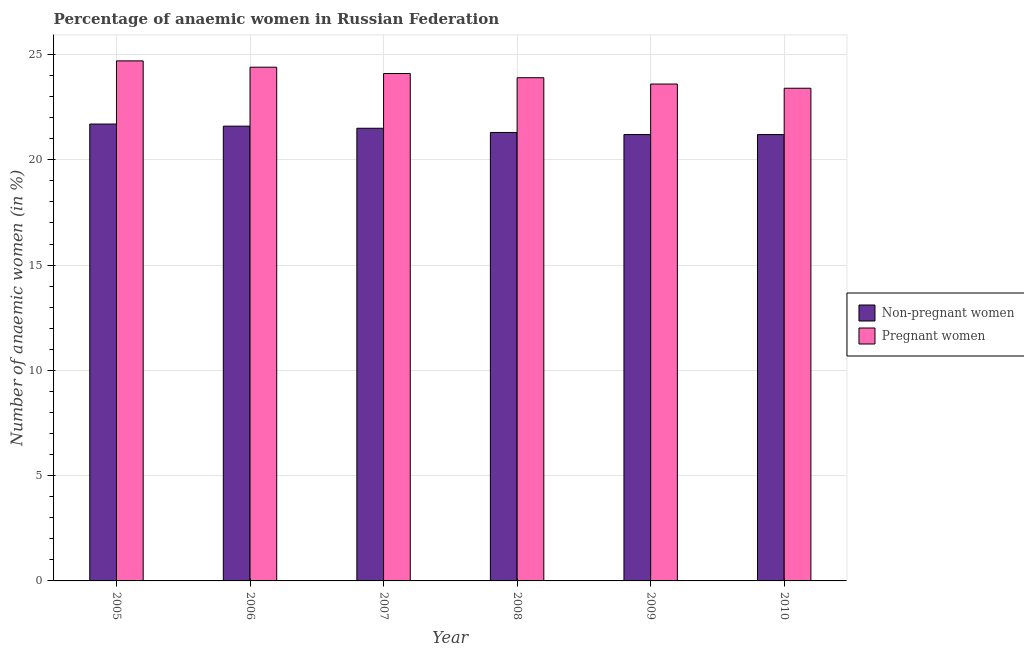How many different coloured bars are there?
Ensure brevity in your answer.  2. How many groups of bars are there?
Provide a short and direct response. 6. Are the number of bars per tick equal to the number of legend labels?
Your answer should be very brief. Yes. Are the number of bars on each tick of the X-axis equal?
Provide a succinct answer. Yes. How many bars are there on the 3rd tick from the left?
Your answer should be very brief. 2. What is the label of the 2nd group of bars from the left?
Offer a terse response. 2006. What is the percentage of non-pregnant anaemic women in 2006?
Ensure brevity in your answer.  21.6. Across all years, what is the maximum percentage of pregnant anaemic women?
Make the answer very short. 24.7. Across all years, what is the minimum percentage of non-pregnant anaemic women?
Give a very brief answer. 21.2. What is the total percentage of pregnant anaemic women in the graph?
Give a very brief answer. 144.1. What is the difference between the percentage of non-pregnant anaemic women in 2007 and that in 2010?
Keep it short and to the point. 0.3. What is the difference between the percentage of non-pregnant anaemic women in 2005 and the percentage of pregnant anaemic women in 2006?
Offer a terse response. 0.1. What is the average percentage of non-pregnant anaemic women per year?
Make the answer very short. 21.42. What is the ratio of the percentage of non-pregnant anaemic women in 2006 to that in 2007?
Make the answer very short. 1. What is the difference between the highest and the second highest percentage of pregnant anaemic women?
Provide a succinct answer. 0.3. What does the 2nd bar from the left in 2005 represents?
Give a very brief answer. Pregnant women. What does the 2nd bar from the right in 2006 represents?
Give a very brief answer. Non-pregnant women. How many bars are there?
Your answer should be very brief. 12. Are all the bars in the graph horizontal?
Ensure brevity in your answer.  No. How many years are there in the graph?
Provide a short and direct response. 6. Are the values on the major ticks of Y-axis written in scientific E-notation?
Give a very brief answer. No. Does the graph contain grids?
Ensure brevity in your answer.  Yes. How many legend labels are there?
Provide a succinct answer. 2. How are the legend labels stacked?
Provide a succinct answer. Vertical. What is the title of the graph?
Offer a very short reply. Percentage of anaemic women in Russian Federation. What is the label or title of the Y-axis?
Offer a terse response. Number of anaemic women (in %). What is the Number of anaemic women (in %) in Non-pregnant women in 2005?
Your response must be concise. 21.7. What is the Number of anaemic women (in %) of Pregnant women in 2005?
Your response must be concise. 24.7. What is the Number of anaemic women (in %) in Non-pregnant women in 2006?
Give a very brief answer. 21.6. What is the Number of anaemic women (in %) of Pregnant women in 2006?
Your answer should be very brief. 24.4. What is the Number of anaemic women (in %) in Pregnant women in 2007?
Give a very brief answer. 24.1. What is the Number of anaemic women (in %) in Non-pregnant women in 2008?
Keep it short and to the point. 21.3. What is the Number of anaemic women (in %) in Pregnant women in 2008?
Provide a succinct answer. 23.9. What is the Number of anaemic women (in %) of Non-pregnant women in 2009?
Your answer should be very brief. 21.2. What is the Number of anaemic women (in %) in Pregnant women in 2009?
Keep it short and to the point. 23.6. What is the Number of anaemic women (in %) of Non-pregnant women in 2010?
Provide a succinct answer. 21.2. What is the Number of anaemic women (in %) in Pregnant women in 2010?
Your answer should be compact. 23.4. Across all years, what is the maximum Number of anaemic women (in %) of Non-pregnant women?
Ensure brevity in your answer.  21.7. Across all years, what is the maximum Number of anaemic women (in %) of Pregnant women?
Offer a very short reply. 24.7. Across all years, what is the minimum Number of anaemic women (in %) in Non-pregnant women?
Give a very brief answer. 21.2. Across all years, what is the minimum Number of anaemic women (in %) in Pregnant women?
Your answer should be compact. 23.4. What is the total Number of anaemic women (in %) of Non-pregnant women in the graph?
Make the answer very short. 128.5. What is the total Number of anaemic women (in %) in Pregnant women in the graph?
Offer a very short reply. 144.1. What is the difference between the Number of anaemic women (in %) of Non-pregnant women in 2005 and that in 2006?
Offer a very short reply. 0.1. What is the difference between the Number of anaemic women (in %) in Pregnant women in 2005 and that in 2006?
Your answer should be compact. 0.3. What is the difference between the Number of anaemic women (in %) in Non-pregnant women in 2006 and that in 2008?
Your answer should be very brief. 0.3. What is the difference between the Number of anaemic women (in %) in Pregnant women in 2006 and that in 2008?
Offer a terse response. 0.5. What is the difference between the Number of anaemic women (in %) of Non-pregnant women in 2007 and that in 2008?
Provide a succinct answer. 0.2. What is the difference between the Number of anaemic women (in %) of Pregnant women in 2007 and that in 2008?
Your answer should be compact. 0.2. What is the difference between the Number of anaemic women (in %) of Non-pregnant women in 2007 and that in 2010?
Keep it short and to the point. 0.3. What is the difference between the Number of anaemic women (in %) of Pregnant women in 2007 and that in 2010?
Your answer should be compact. 0.7. What is the difference between the Number of anaemic women (in %) of Non-pregnant women in 2008 and that in 2009?
Offer a terse response. 0.1. What is the difference between the Number of anaemic women (in %) in Pregnant women in 2008 and that in 2009?
Keep it short and to the point. 0.3. What is the difference between the Number of anaemic women (in %) in Pregnant women in 2008 and that in 2010?
Your answer should be compact. 0.5. What is the difference between the Number of anaemic women (in %) in Non-pregnant women in 2005 and the Number of anaemic women (in %) in Pregnant women in 2007?
Provide a short and direct response. -2.4. What is the difference between the Number of anaemic women (in %) in Non-pregnant women in 2005 and the Number of anaemic women (in %) in Pregnant women in 2009?
Your response must be concise. -1.9. What is the difference between the Number of anaemic women (in %) of Non-pregnant women in 2005 and the Number of anaemic women (in %) of Pregnant women in 2010?
Keep it short and to the point. -1.7. What is the difference between the Number of anaemic women (in %) of Non-pregnant women in 2006 and the Number of anaemic women (in %) of Pregnant women in 2007?
Offer a terse response. -2.5. What is the difference between the Number of anaemic women (in %) in Non-pregnant women in 2006 and the Number of anaemic women (in %) in Pregnant women in 2008?
Your answer should be very brief. -2.3. What is the difference between the Number of anaemic women (in %) in Non-pregnant women in 2006 and the Number of anaemic women (in %) in Pregnant women in 2009?
Your answer should be very brief. -2. What is the difference between the Number of anaemic women (in %) in Non-pregnant women in 2007 and the Number of anaemic women (in %) in Pregnant women in 2008?
Your answer should be very brief. -2.4. What is the difference between the Number of anaemic women (in %) of Non-pregnant women in 2007 and the Number of anaemic women (in %) of Pregnant women in 2010?
Make the answer very short. -1.9. What is the difference between the Number of anaemic women (in %) of Non-pregnant women in 2008 and the Number of anaemic women (in %) of Pregnant women in 2010?
Provide a short and direct response. -2.1. What is the difference between the Number of anaemic women (in %) in Non-pregnant women in 2009 and the Number of anaemic women (in %) in Pregnant women in 2010?
Make the answer very short. -2.2. What is the average Number of anaemic women (in %) in Non-pregnant women per year?
Provide a short and direct response. 21.42. What is the average Number of anaemic women (in %) in Pregnant women per year?
Your answer should be compact. 24.02. In the year 2006, what is the difference between the Number of anaemic women (in %) of Non-pregnant women and Number of anaemic women (in %) of Pregnant women?
Your answer should be very brief. -2.8. In the year 2007, what is the difference between the Number of anaemic women (in %) of Non-pregnant women and Number of anaemic women (in %) of Pregnant women?
Give a very brief answer. -2.6. In the year 2008, what is the difference between the Number of anaemic women (in %) in Non-pregnant women and Number of anaemic women (in %) in Pregnant women?
Your response must be concise. -2.6. What is the ratio of the Number of anaemic women (in %) of Non-pregnant women in 2005 to that in 2006?
Offer a very short reply. 1. What is the ratio of the Number of anaemic women (in %) of Pregnant women in 2005 to that in 2006?
Make the answer very short. 1.01. What is the ratio of the Number of anaemic women (in %) of Non-pregnant women in 2005 to that in 2007?
Offer a very short reply. 1.01. What is the ratio of the Number of anaemic women (in %) of Pregnant women in 2005 to that in 2007?
Keep it short and to the point. 1.02. What is the ratio of the Number of anaemic women (in %) in Non-pregnant women in 2005 to that in 2008?
Provide a succinct answer. 1.02. What is the ratio of the Number of anaemic women (in %) of Pregnant women in 2005 to that in 2008?
Provide a short and direct response. 1.03. What is the ratio of the Number of anaemic women (in %) in Non-pregnant women in 2005 to that in 2009?
Provide a succinct answer. 1.02. What is the ratio of the Number of anaemic women (in %) of Pregnant women in 2005 to that in 2009?
Provide a succinct answer. 1.05. What is the ratio of the Number of anaemic women (in %) in Non-pregnant women in 2005 to that in 2010?
Your answer should be compact. 1.02. What is the ratio of the Number of anaemic women (in %) of Pregnant women in 2005 to that in 2010?
Your answer should be very brief. 1.06. What is the ratio of the Number of anaemic women (in %) of Non-pregnant women in 2006 to that in 2007?
Offer a terse response. 1. What is the ratio of the Number of anaemic women (in %) in Pregnant women in 2006 to that in 2007?
Make the answer very short. 1.01. What is the ratio of the Number of anaemic women (in %) of Non-pregnant women in 2006 to that in 2008?
Ensure brevity in your answer.  1.01. What is the ratio of the Number of anaemic women (in %) of Pregnant women in 2006 to that in 2008?
Your answer should be very brief. 1.02. What is the ratio of the Number of anaemic women (in %) of Non-pregnant women in 2006 to that in 2009?
Make the answer very short. 1.02. What is the ratio of the Number of anaemic women (in %) in Pregnant women in 2006 to that in 2009?
Make the answer very short. 1.03. What is the ratio of the Number of anaemic women (in %) in Non-pregnant women in 2006 to that in 2010?
Your response must be concise. 1.02. What is the ratio of the Number of anaemic women (in %) of Pregnant women in 2006 to that in 2010?
Your response must be concise. 1.04. What is the ratio of the Number of anaemic women (in %) of Non-pregnant women in 2007 to that in 2008?
Ensure brevity in your answer.  1.01. What is the ratio of the Number of anaemic women (in %) of Pregnant women in 2007 to that in 2008?
Your answer should be compact. 1.01. What is the ratio of the Number of anaemic women (in %) in Non-pregnant women in 2007 to that in 2009?
Provide a succinct answer. 1.01. What is the ratio of the Number of anaemic women (in %) of Pregnant women in 2007 to that in 2009?
Provide a succinct answer. 1.02. What is the ratio of the Number of anaemic women (in %) in Non-pregnant women in 2007 to that in 2010?
Your response must be concise. 1.01. What is the ratio of the Number of anaemic women (in %) in Pregnant women in 2007 to that in 2010?
Offer a terse response. 1.03. What is the ratio of the Number of anaemic women (in %) in Non-pregnant women in 2008 to that in 2009?
Ensure brevity in your answer.  1. What is the ratio of the Number of anaemic women (in %) in Pregnant women in 2008 to that in 2009?
Your answer should be very brief. 1.01. What is the ratio of the Number of anaemic women (in %) of Non-pregnant women in 2008 to that in 2010?
Provide a short and direct response. 1. What is the ratio of the Number of anaemic women (in %) in Pregnant women in 2008 to that in 2010?
Provide a short and direct response. 1.02. What is the ratio of the Number of anaemic women (in %) of Non-pregnant women in 2009 to that in 2010?
Provide a short and direct response. 1. What is the ratio of the Number of anaemic women (in %) in Pregnant women in 2009 to that in 2010?
Your answer should be compact. 1.01. What is the difference between the highest and the second highest Number of anaemic women (in %) of Non-pregnant women?
Ensure brevity in your answer.  0.1. What is the difference between the highest and the lowest Number of anaemic women (in %) in Non-pregnant women?
Ensure brevity in your answer.  0.5. 